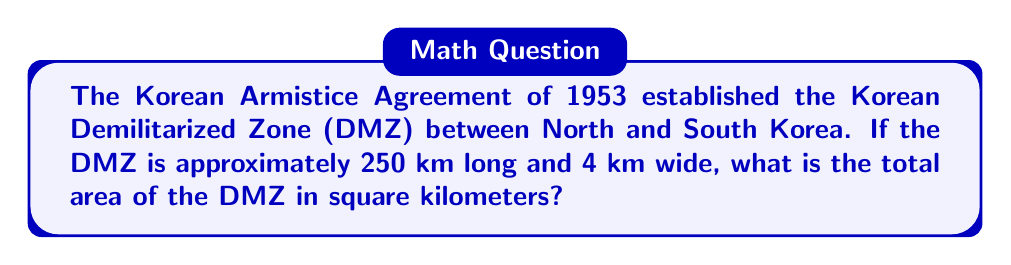Provide a solution to this math problem. To find the area of the DMZ, we need to use the formula for the area of a rectangle:

$$ A = l \times w $$

Where:
$A$ = area
$l$ = length
$w$ = width

Given:
- Length of DMZ: $l = 250$ km
- Width of DMZ: $w = 4$ km

Let's substitute these values into the formula:

$$ A = 250 \text{ km} \times 4 \text{ km} $$

Now, we can perform the multiplication:

$$ A = 1000 \text{ km}^2 $$

Therefore, the total area of the Korean Demilitarized Zone is 1000 square kilometers.
Answer: $1000 \text{ km}^2$ 